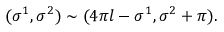<formula> <loc_0><loc_0><loc_500><loc_500>( \sigma ^ { 1 } , \sigma ^ { 2 } ) \sim ( 4 \pi l - \sigma ^ { 1 } , \sigma ^ { 2 } + \pi ) .</formula> 